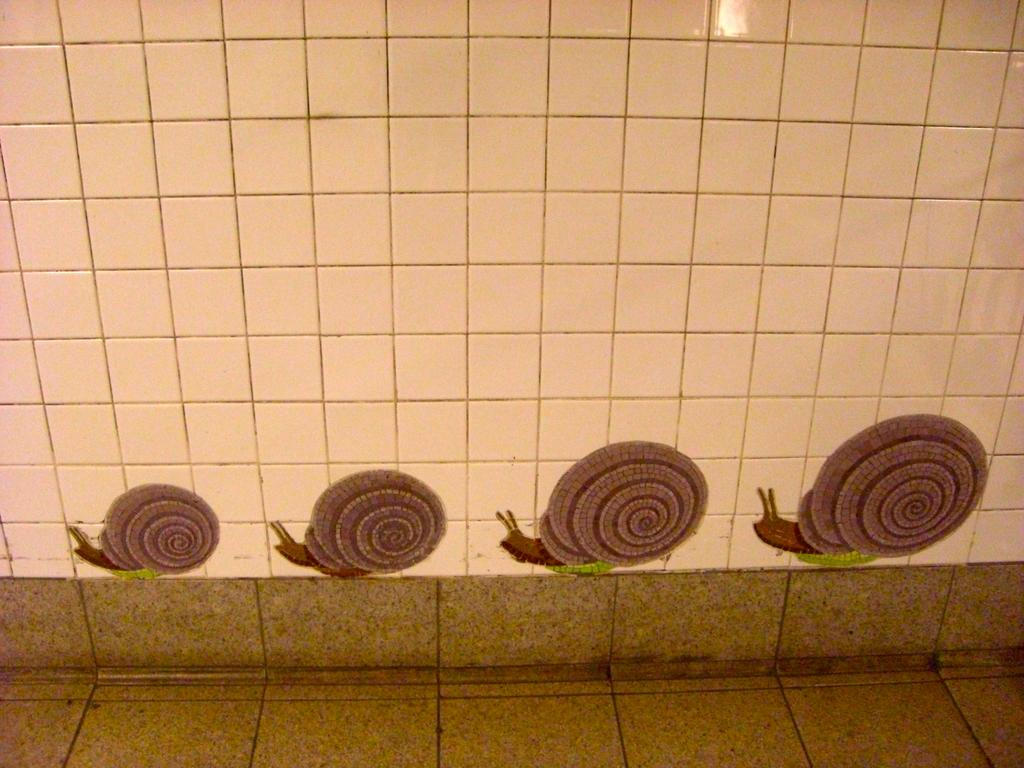What is present on the wall in the image? There are tiles on the wall in the image. What design can be seen on the tiles? There is a design of four snails on the wall. What color are the snails in the design? The snails are in brown color. What type of cheese is visible on the wall in the image? There is no cheese present on the wall in the image. What part of the human body can be seen in the image? There is no human body present in the image; it only features a wall with tiles and a snail design. 